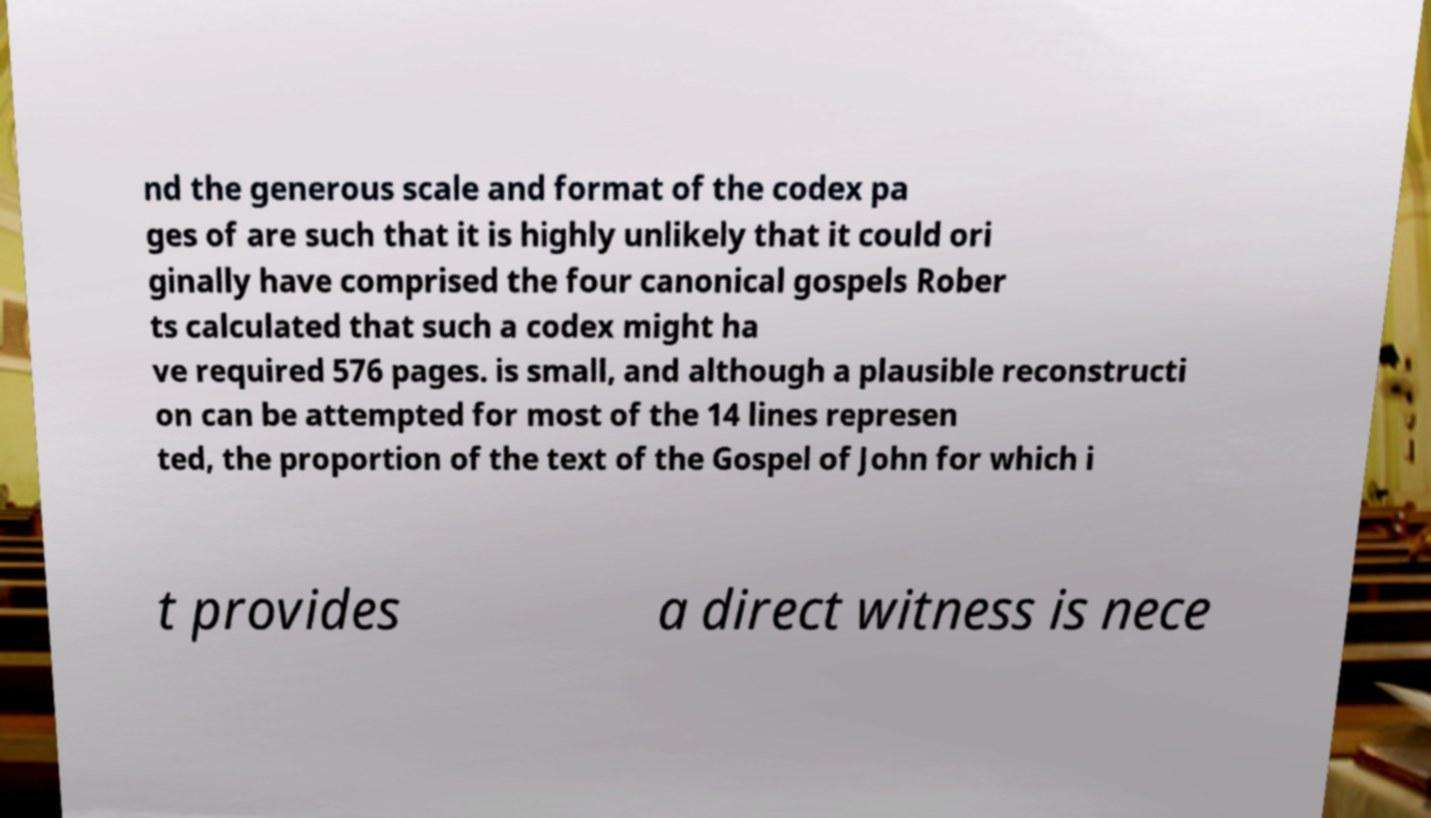What messages or text are displayed in this image? I need them in a readable, typed format. nd the generous scale and format of the codex pa ges of are such that it is highly unlikely that it could ori ginally have comprised the four canonical gospels Rober ts calculated that such a codex might ha ve required 576 pages. is small, and although a plausible reconstructi on can be attempted for most of the 14 lines represen ted, the proportion of the text of the Gospel of John for which i t provides a direct witness is nece 